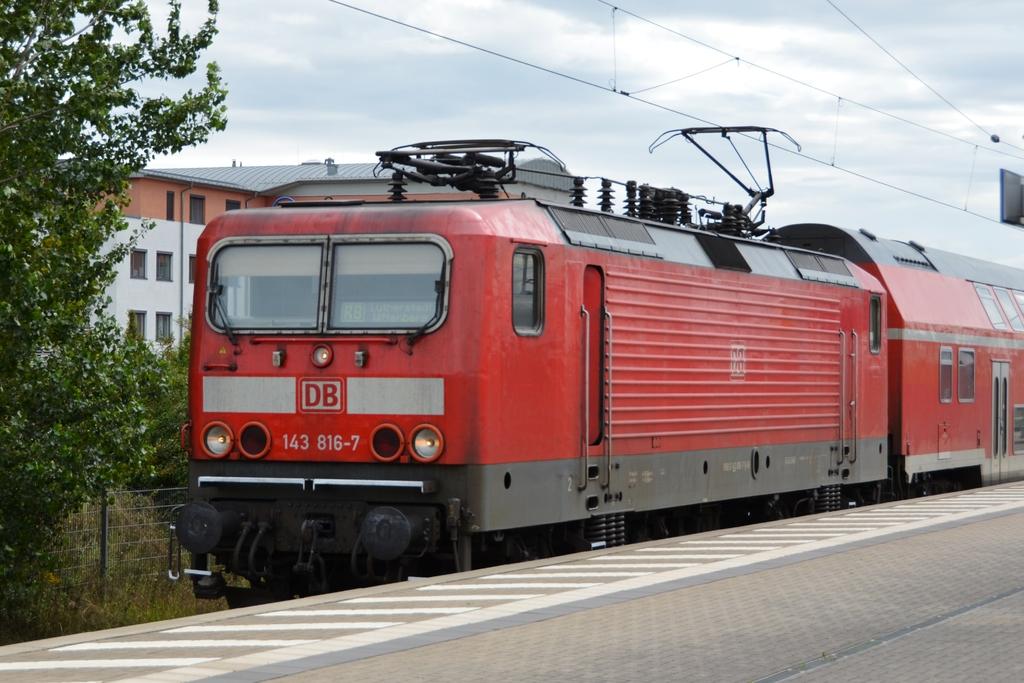What letters are on the train?
Your answer should be compact. Db. What are the numbers on the front of the train?
Your response must be concise. 143 816-7. 